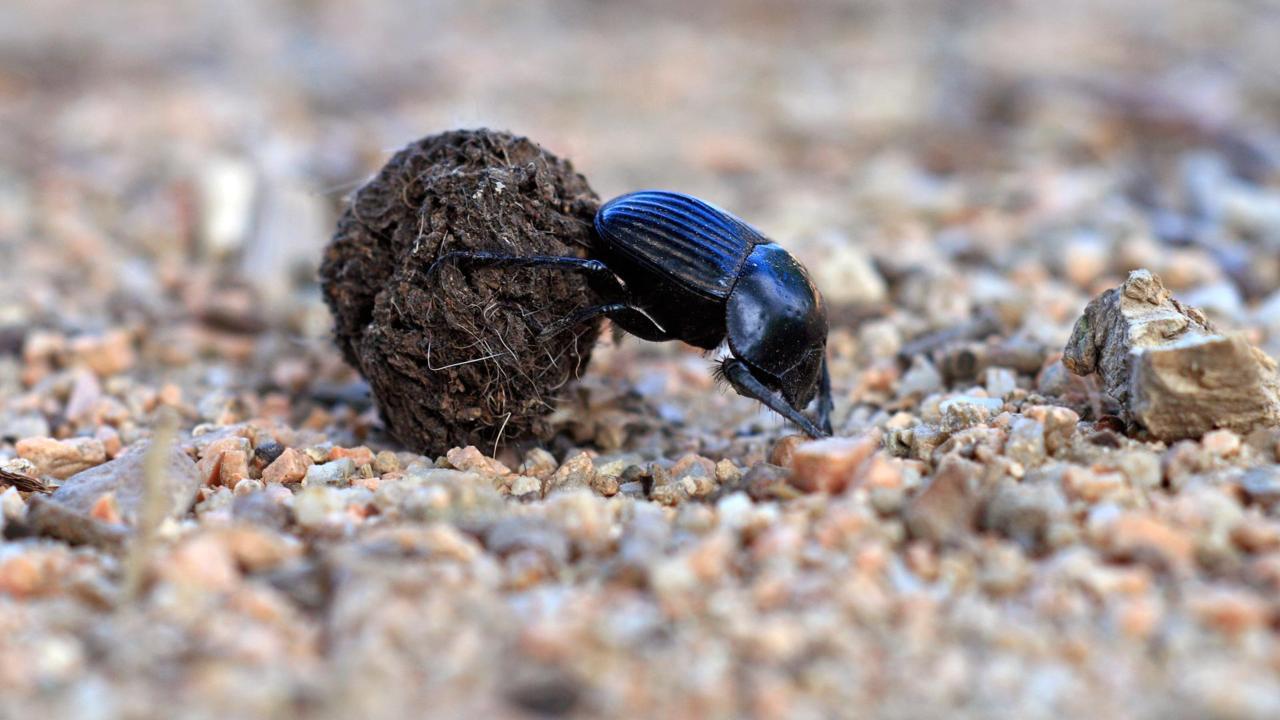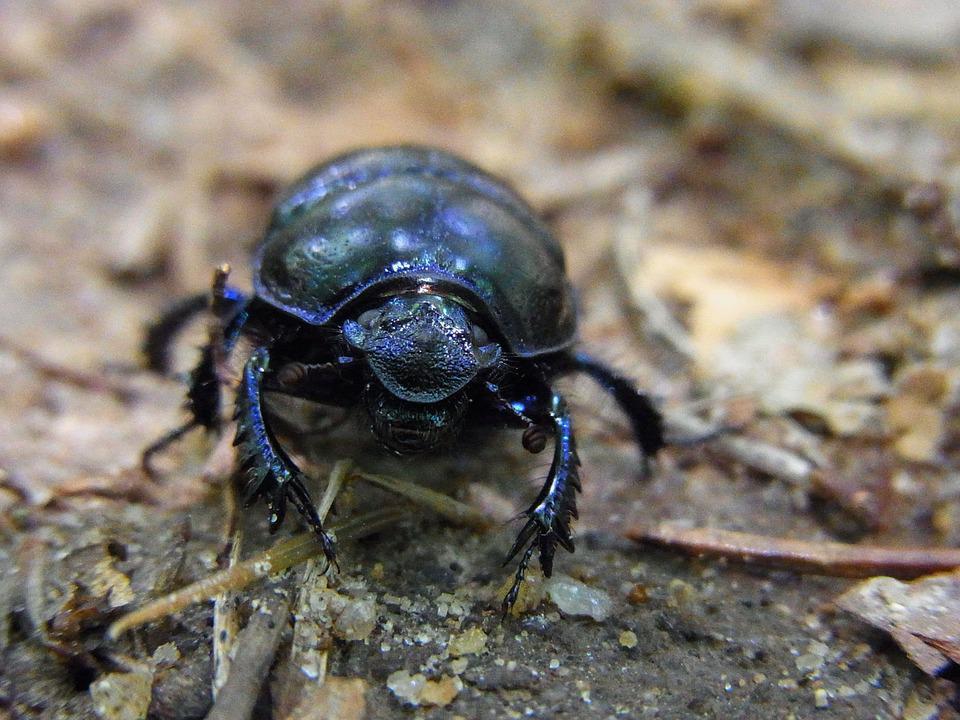The first image is the image on the left, the second image is the image on the right. Evaluate the accuracy of this statement regarding the images: "There are exactly two insects in one of the images.". Is it true? Answer yes or no. No. 